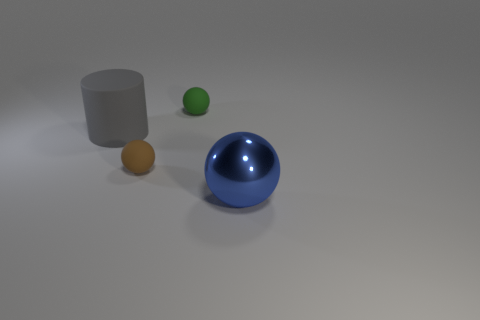The green thing that is the same shape as the blue shiny object is what size?
Your answer should be compact. Small. Is there any other thing that has the same material as the small green thing?
Ensure brevity in your answer.  Yes. Are there any shiny things?
Your response must be concise. Yes. There is a big ball; is it the same color as the object that is left of the brown ball?
Offer a very short reply. No. How big is the sphere to the left of the matte sphere behind the small rubber thing in front of the green thing?
Ensure brevity in your answer.  Small. What number of objects have the same color as the cylinder?
Your response must be concise. 0. How many objects are small matte balls or objects that are behind the blue metallic ball?
Offer a very short reply. 3. What is the color of the big cylinder?
Your answer should be compact. Gray. What color is the tiny matte object that is in front of the gray rubber object?
Provide a succinct answer. Brown. What number of objects are on the right side of the small rubber object in front of the big rubber cylinder?
Offer a terse response. 2. 